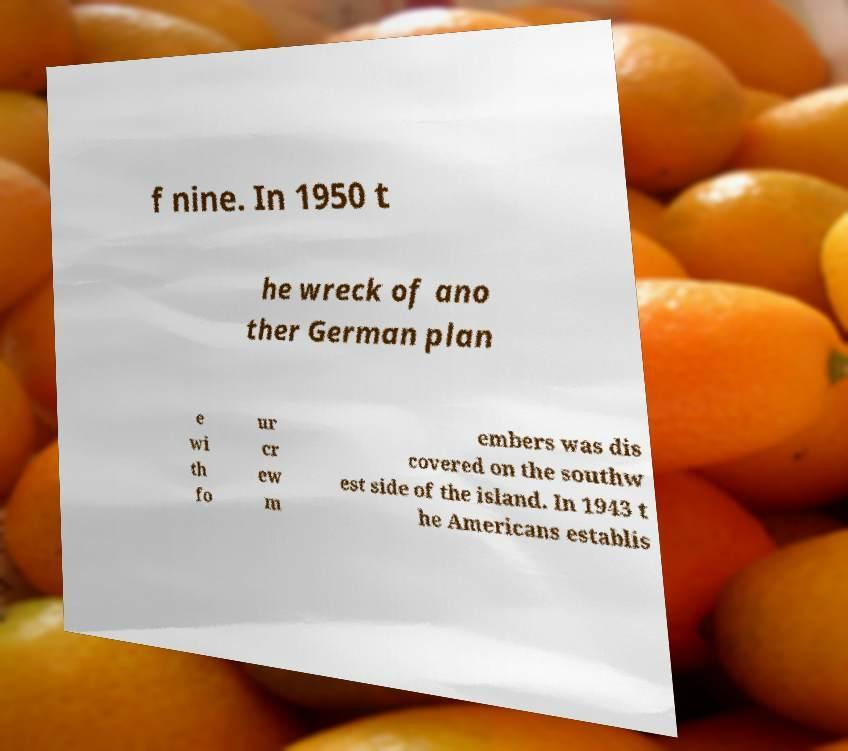What messages or text are displayed in this image? I need them in a readable, typed format. f nine. In 1950 t he wreck of ano ther German plan e wi th fo ur cr ew m embers was dis covered on the southw est side of the island. In 1943 t he Americans establis 